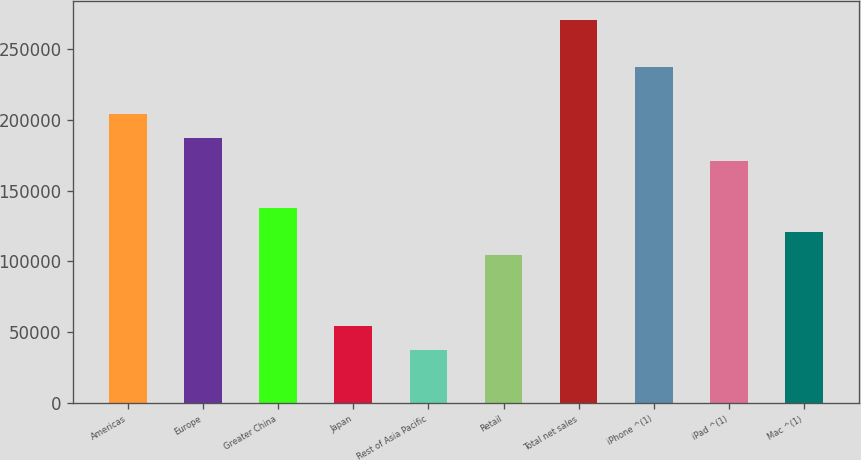Convert chart. <chart><loc_0><loc_0><loc_500><loc_500><bar_chart><fcel>Americas<fcel>Europe<fcel>Greater China<fcel>Japan<fcel>Rest of Asia Pacific<fcel>Retail<fcel>Total net sales<fcel>iPhone ^(1)<fcel>iPad ^(1)<fcel>Mac ^(1)<nl><fcel>204210<fcel>187560<fcel>137610<fcel>54360.7<fcel>37710.8<fcel>104310<fcel>270809<fcel>237510<fcel>170910<fcel>120960<nl></chart> 